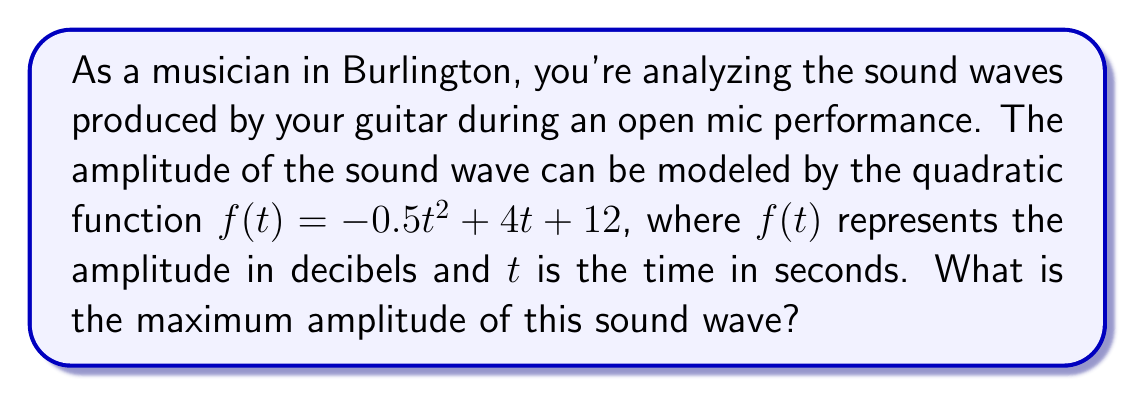Show me your answer to this math problem. To find the maximum amplitude of the sound wave, we need to determine the vertex of the quadratic function. The vertex represents the highest point of the parabola, which corresponds to the maximum amplitude in this case.

For a quadratic function in the form $f(t) = at^2 + bt + c$, we can find the t-coordinate of the vertex using the formula:

$$t = -\frac{b}{2a}$$

In our function $f(t) = -0.5t^2 + 4t + 12$, we have:
$a = -0.5$
$b = 4$
$c = 12$

Substituting these values into the formula:

$$t = -\frac{4}{2(-0.5)} = -\frac{4}{-1} = 4$$

So, the t-coordinate of the vertex is 4 seconds.

To find the maximum amplitude, we need to calculate $f(4)$:

$$f(4) = -0.5(4)^2 + 4(4) + 12$$
$$= -0.5(16) + 16 + 12$$
$$= -8 + 16 + 12$$
$$= 20$$

Therefore, the maximum amplitude of the sound wave is 20 decibels.
Answer: The maximum amplitude of the sound wave is 20 decibels. 